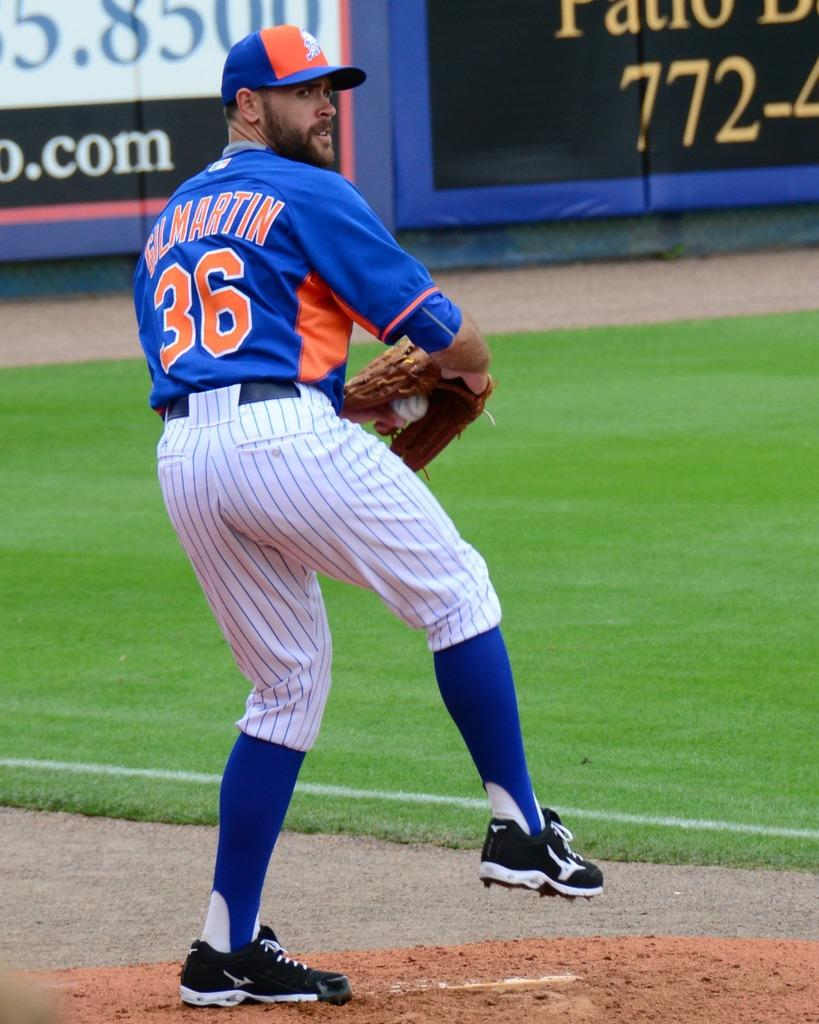<image>
Summarize the visual content of the image. a bullpen on a field with a player wearing the number 36 